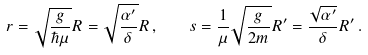Convert formula to latex. <formula><loc_0><loc_0><loc_500><loc_500>r = \sqrt { \frac { g } { \hbar { \mu } } } R = \sqrt { \frac { \alpha ^ { \prime } } { \delta } } R \, , \quad s = \frac { 1 } { \mu } \sqrt { \frac { g } { 2 m } } R ^ { \prime } = \frac { \sqrt { \alpha ^ { \prime } } } { \delta } R ^ { \prime } \, .</formula> 